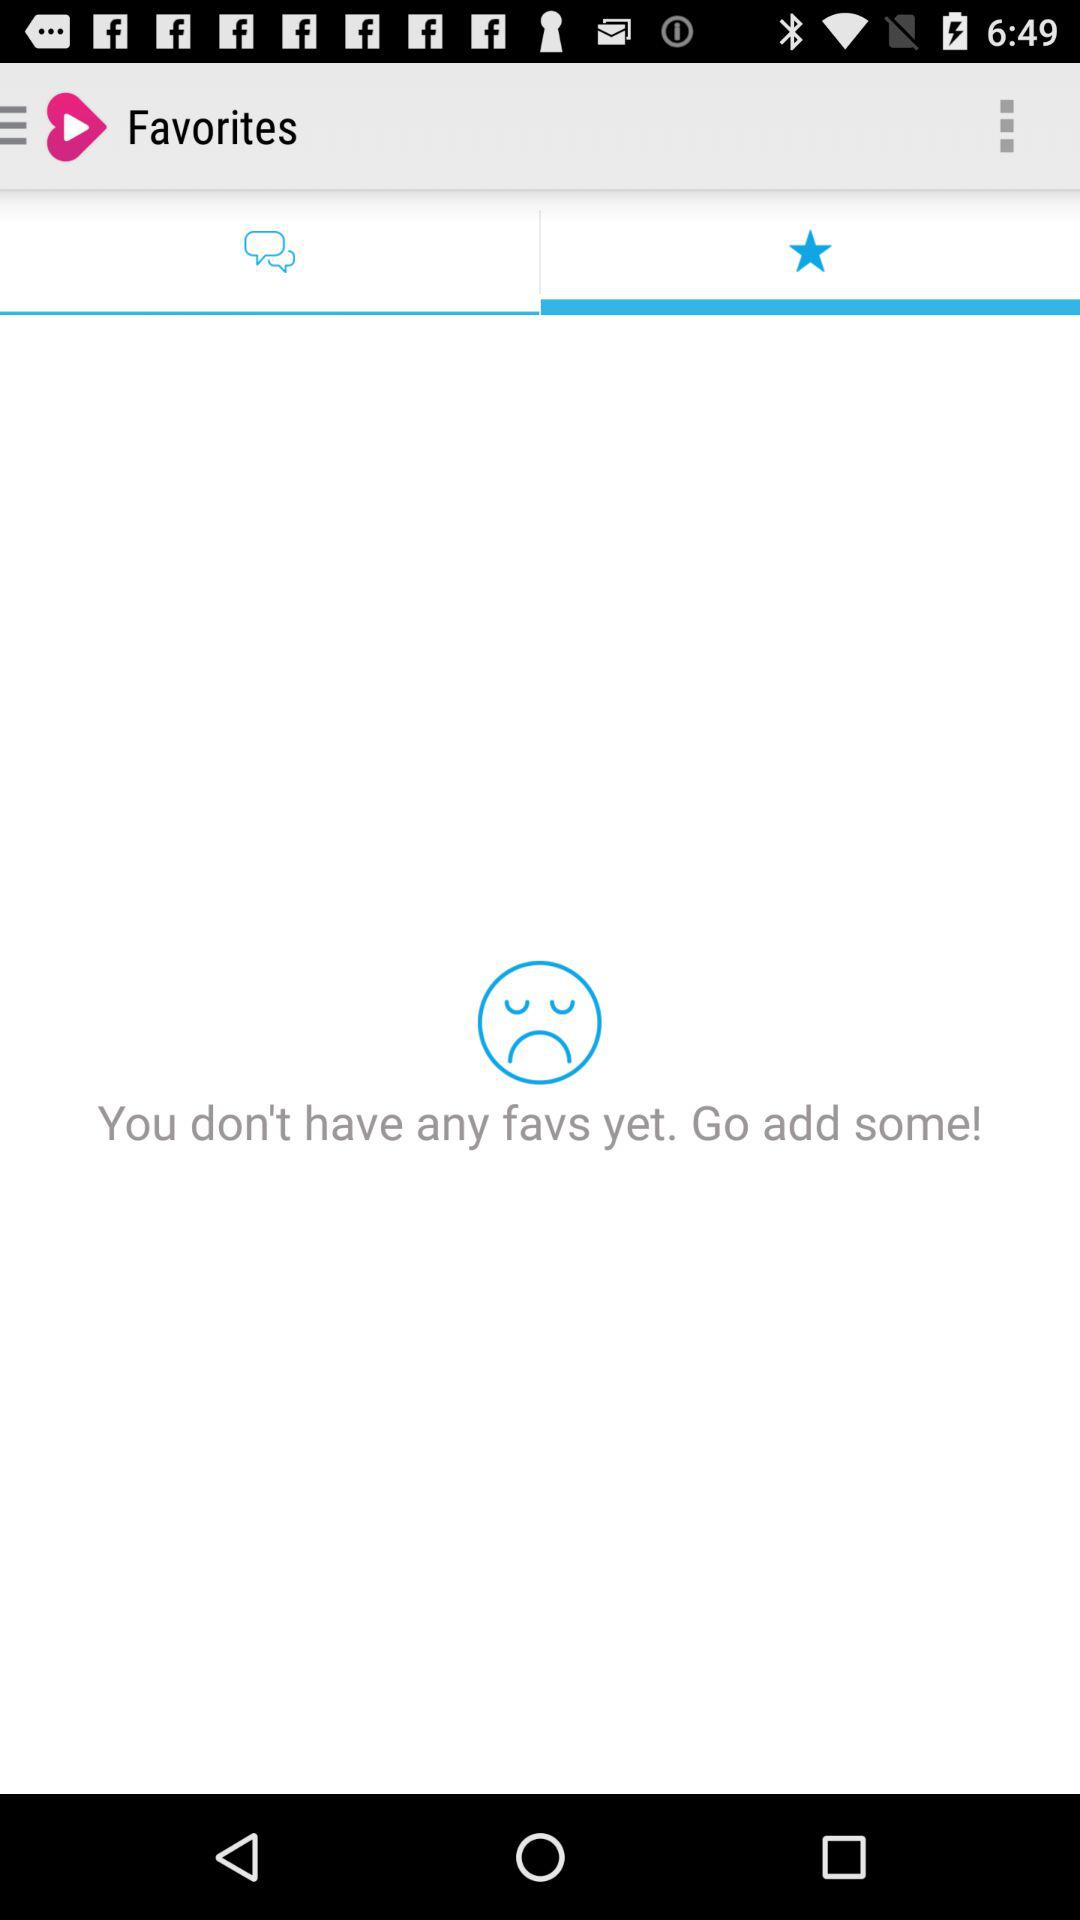How many favorites are there? There are no favorites yet. 